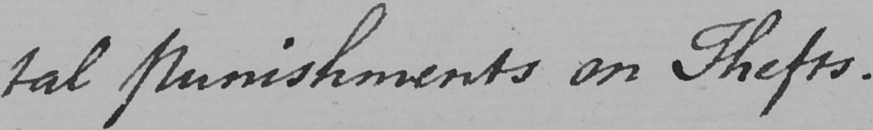What text is written in this handwritten line? -tal Punishments on Thefts . 